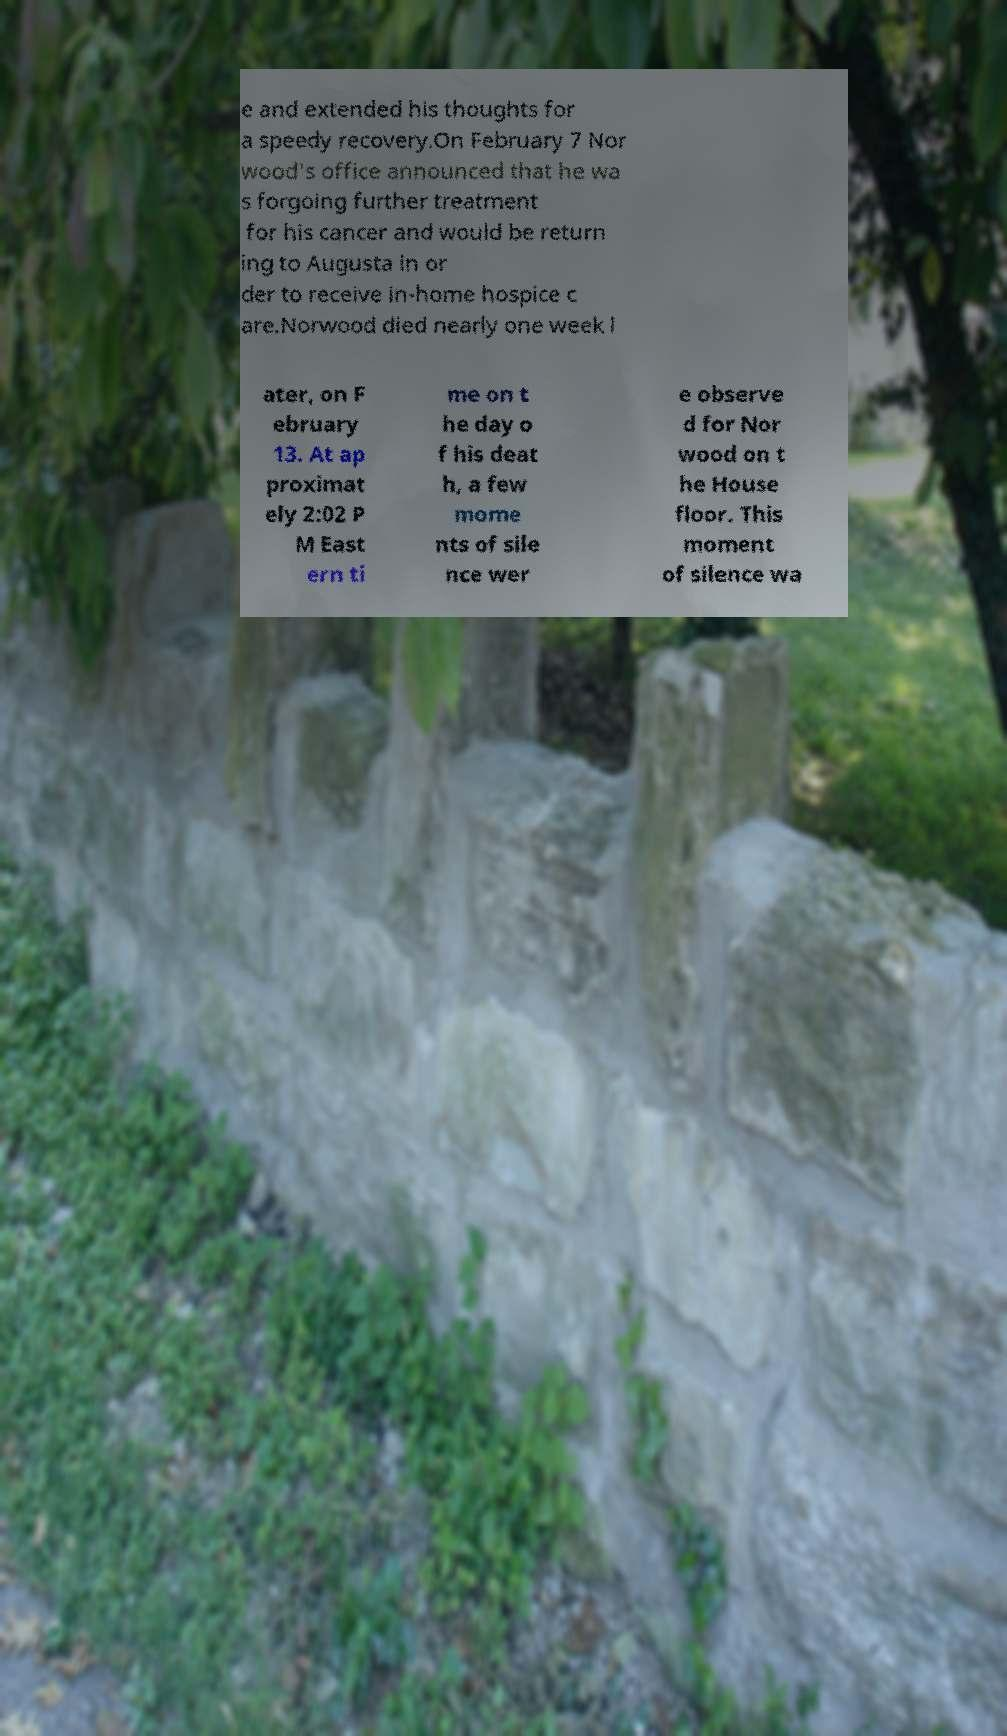Could you extract and type out the text from this image? e and extended his thoughts for a speedy recovery.On February 7 Nor wood's office announced that he wa s forgoing further treatment for his cancer and would be return ing to Augusta in or der to receive in-home hospice c are.Norwood died nearly one week l ater, on F ebruary 13. At ap proximat ely 2:02 P M East ern ti me on t he day o f his deat h, a few mome nts of sile nce wer e observe d for Nor wood on t he House floor. This moment of silence wa 